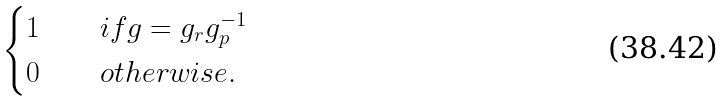Convert formula to latex. <formula><loc_0><loc_0><loc_500><loc_500>\begin{cases} 1 \quad & i f g = g _ { r } g _ { p } ^ { - 1 } \\ 0 \quad & o t h e r w i s e . \end{cases}</formula> 